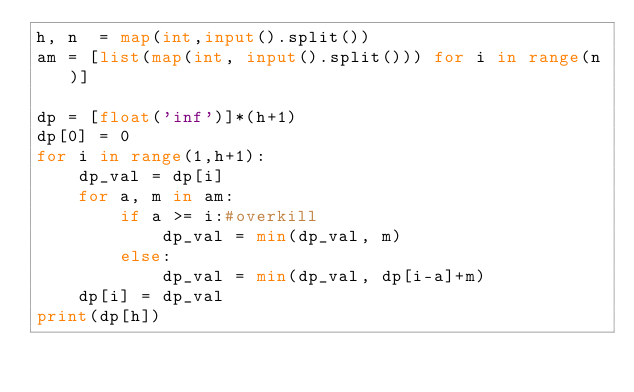Convert code to text. <code><loc_0><loc_0><loc_500><loc_500><_Python_>h, n  = map(int,input().split())
am = [list(map(int, input().split())) for i in range(n)] 

dp = [float('inf')]*(h+1)
dp[0] = 0
for i in range(1,h+1):
    dp_val = dp[i]
    for a, m in am:
        if a >= i:#overkill
            dp_val = min(dp_val, m)
        else:
            dp_val = min(dp_val, dp[i-a]+m)
    dp[i] = dp_val
print(dp[h])
    
</code> 